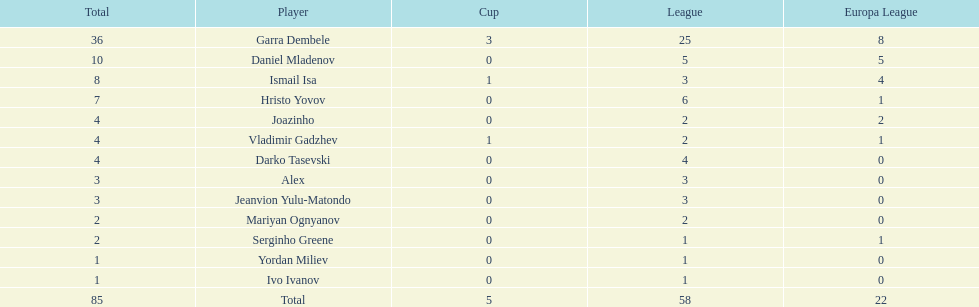Which player is in the same league as joazinho and vladimir gadzhev? Mariyan Ognyanov. 